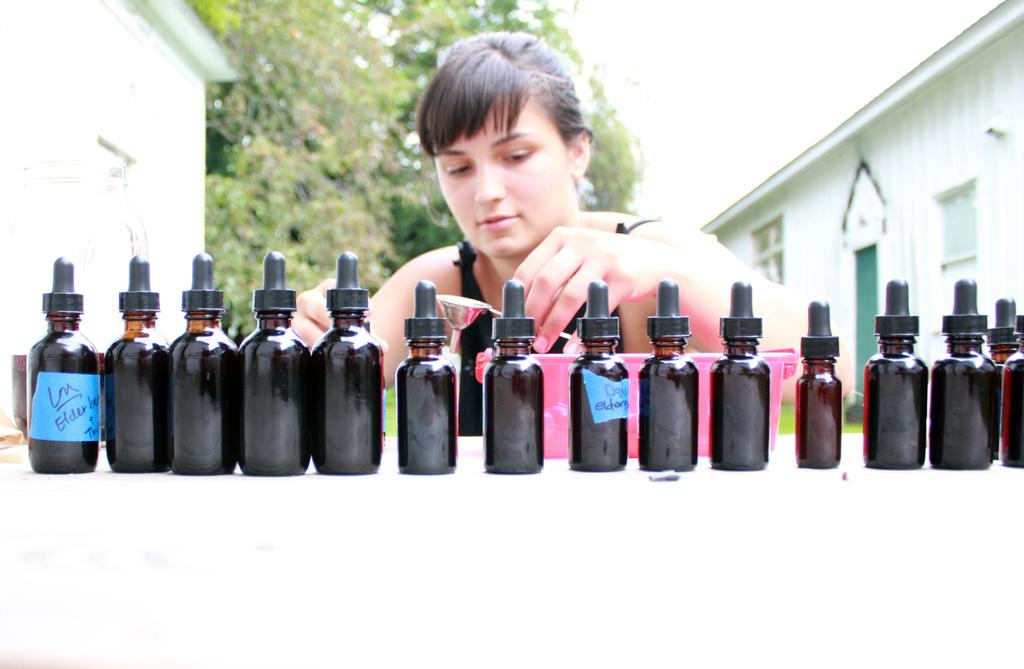Who is the main subject in the image? There is a woman in the image. What is the woman's position in relation to the table? The woman is in front of a table. What objects can be seen on the table? There are bottles on the table. What type of structures are visible in the image? There are houses visible in the image. What type of vegetation is visible in the image? There are trees visible in the image. What type of debt is being discussed in the image? There is no mention of debt in the image; it features a woman in front of a table with bottles and a background of houses and trees. What type of bait is being used to catch fish in the image? There is no fishing or bait present in the image. 